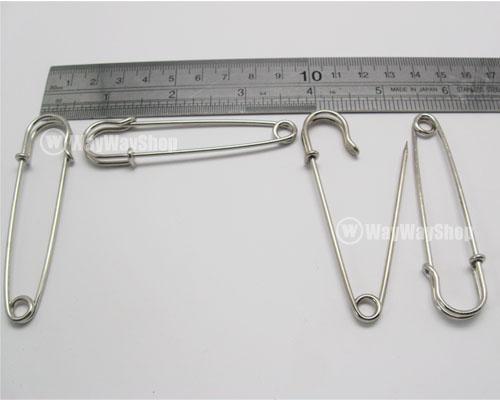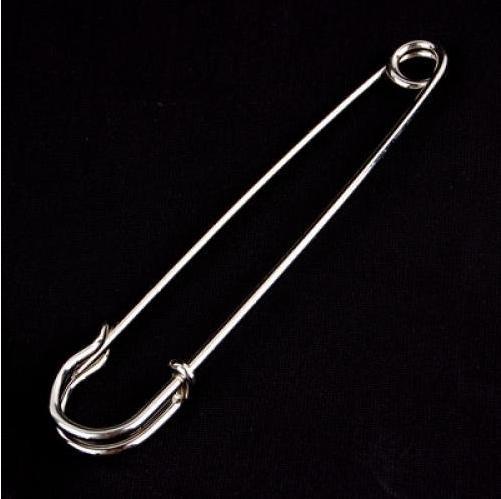The first image is the image on the left, the second image is the image on the right. For the images shown, is this caption "One image contains exactly two safety pins." true? Answer yes or no. No. 